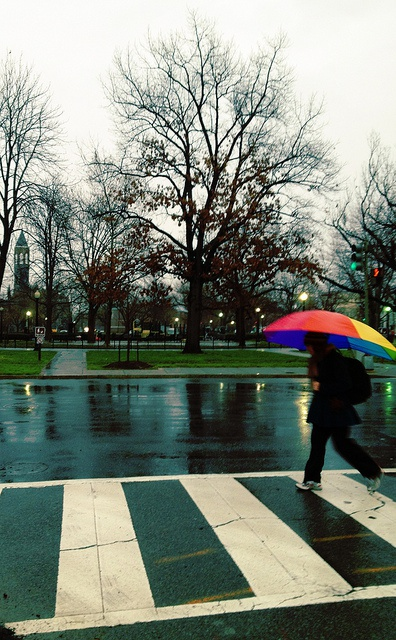Describe the objects in this image and their specific colors. I can see people in white, black, teal, and darkgreen tones, umbrella in white, salmon, darkblue, gold, and red tones, backpack in white, black, and darkgreen tones, and traffic light in white, black, teal, and darkgray tones in this image. 